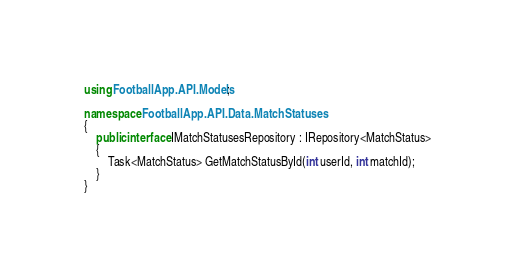Convert code to text. <code><loc_0><loc_0><loc_500><loc_500><_C#_>using FootballApp.API.Models;

namespace FootballApp.API.Data.MatchStatuses
{
    public interface IMatchStatusesRepository : IRepository<MatchStatus>
    {
        Task<MatchStatus> GetMatchStatusById(int userId, int matchId);
    }
}</code> 